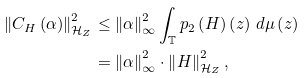Convert formula to latex. <formula><loc_0><loc_0><loc_500><loc_500>\left \| C _ { H } \left ( \alpha \right ) \right \| _ { \mathcal { H } _ { Z } } ^ { 2 } & \leq \left \| \alpha \right \| _ { \infty } ^ { 2 } \int _ { \mathbb { T } } p _ { 2 } \left ( H \right ) \left ( z \right ) \, d \mu \left ( z \right ) \\ & = \left \| \alpha \right \| _ { \infty } ^ { 2 } \cdot \left \| H \right \| _ { \mathcal { H } _ { Z } } ^ { 2 } ,</formula> 